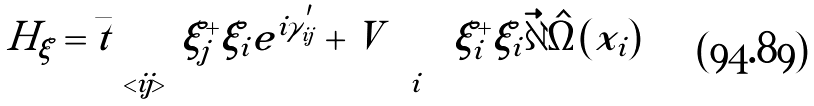<formula> <loc_0><loc_0><loc_500><loc_500>H _ { \xi } = \bar { t } \sum _ { < i j > } \xi ^ { + } _ { j } \xi _ { i } e ^ { i \gamma _ { i j } ^ { ^ { \prime } } } + V \sum _ { i } \xi ^ { + } _ { i } \xi _ { i } | \vec { \partial } \hat { \Omega } ( x _ { i } ) |</formula> 